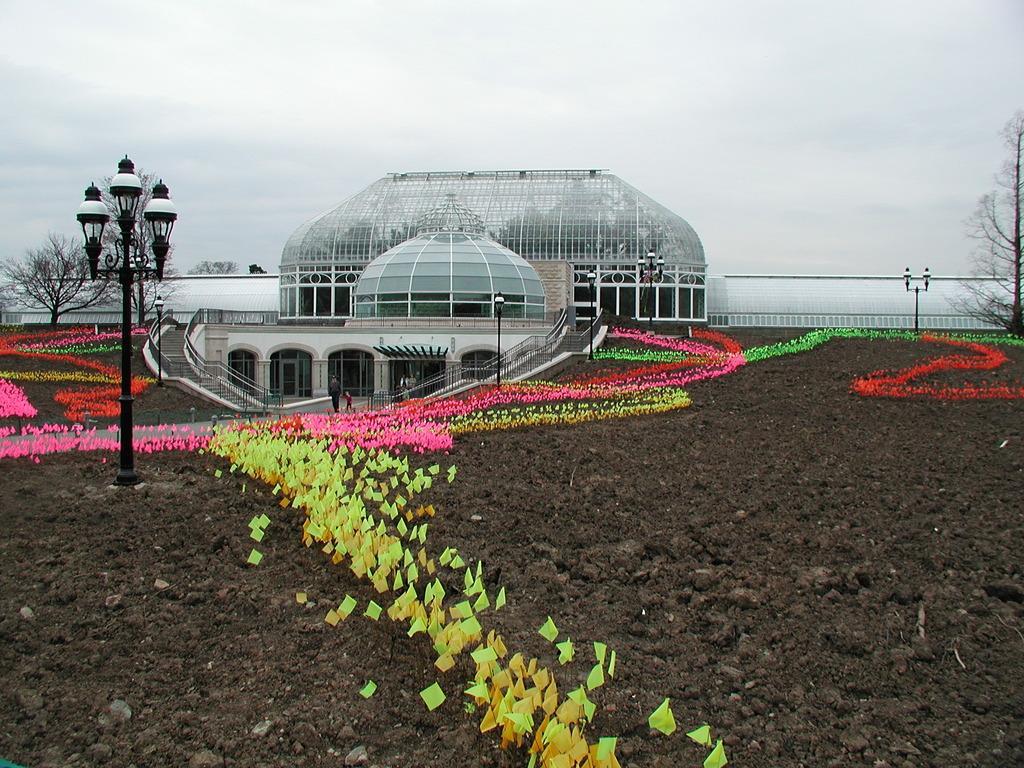How would you summarize this image in a sentence or two? At the center of the image there is a building, in front of the buildings there are few objects arranged on the surface and there is a pole with lamps. In the background there are trees and the sky. 